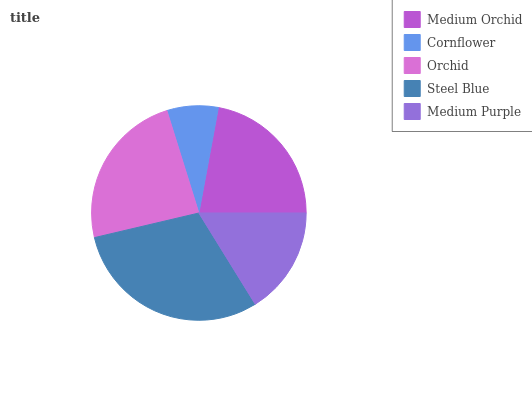Is Cornflower the minimum?
Answer yes or no. Yes. Is Steel Blue the maximum?
Answer yes or no. Yes. Is Orchid the minimum?
Answer yes or no. No. Is Orchid the maximum?
Answer yes or no. No. Is Orchid greater than Cornflower?
Answer yes or no. Yes. Is Cornflower less than Orchid?
Answer yes or no. Yes. Is Cornflower greater than Orchid?
Answer yes or no. No. Is Orchid less than Cornflower?
Answer yes or no. No. Is Medium Orchid the high median?
Answer yes or no. Yes. Is Medium Orchid the low median?
Answer yes or no. Yes. Is Cornflower the high median?
Answer yes or no. No. Is Medium Purple the low median?
Answer yes or no. No. 